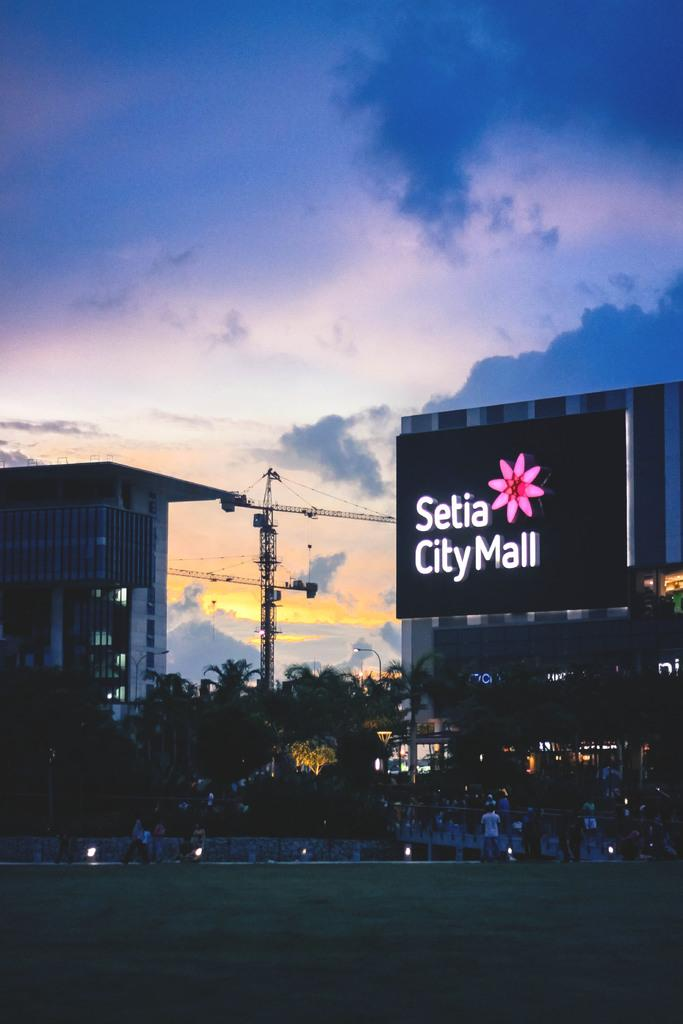What is the primary surface on which people are standing in the image? There is a ground in the image, and people are standing on it. What can be seen in the background of the image? Buildings and trees are visible in the background. Can you describe any specific features of the buildings? There is a hoarding on one of the buildings. What type of sticks are being used to eat the meal in the image? There is no meal or sticks present in the image. What is the aftermath of the event in the image? There is no event or aftermath depicted in the image; it shows people standing on the ground with buildings and trees in the background. 